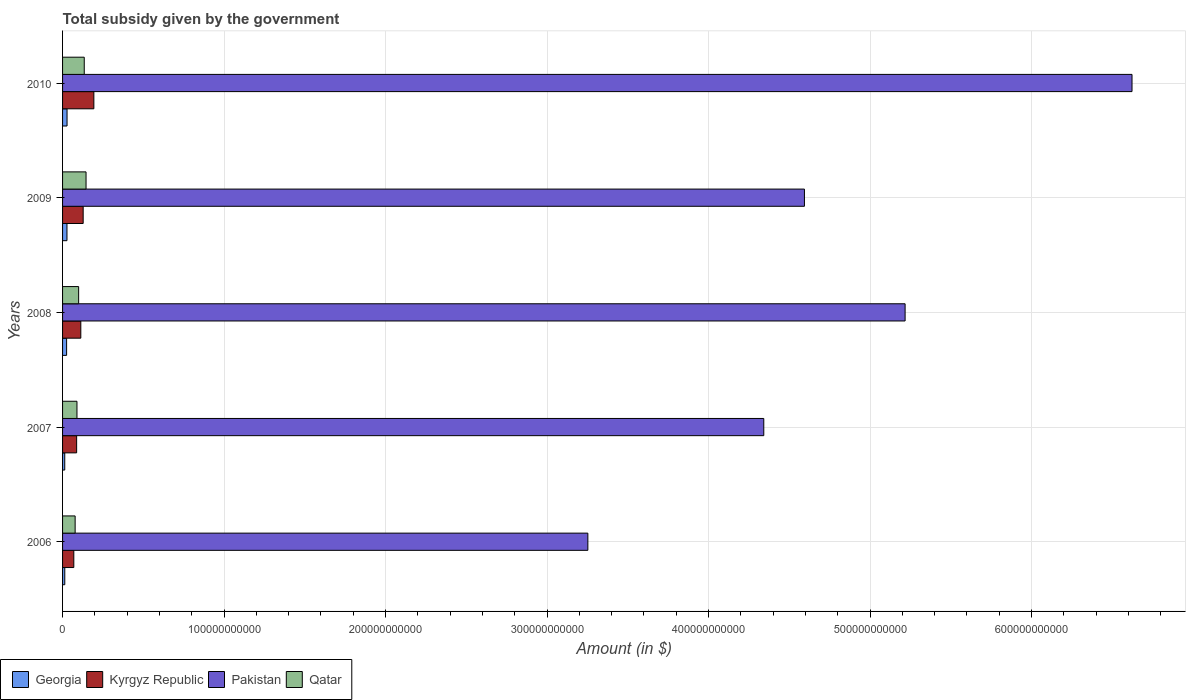Are the number of bars per tick equal to the number of legend labels?
Your answer should be very brief. Yes. What is the label of the 4th group of bars from the top?
Ensure brevity in your answer.  2007. In how many cases, is the number of bars for a given year not equal to the number of legend labels?
Provide a short and direct response. 0. What is the total revenue collected by the government in Qatar in 2008?
Your response must be concise. 9.95e+09. Across all years, what is the maximum total revenue collected by the government in Pakistan?
Provide a succinct answer. 6.62e+11. Across all years, what is the minimum total revenue collected by the government in Georgia?
Provide a short and direct response. 1.36e+09. In which year was the total revenue collected by the government in Kyrgyz Republic minimum?
Offer a very short reply. 2006. What is the total total revenue collected by the government in Georgia in the graph?
Offer a very short reply. 1.07e+1. What is the difference between the total revenue collected by the government in Kyrgyz Republic in 2006 and that in 2009?
Make the answer very short. -5.79e+09. What is the difference between the total revenue collected by the government in Kyrgyz Republic in 2009 and the total revenue collected by the government in Qatar in 2008?
Your answer should be very brief. 2.81e+09. What is the average total revenue collected by the government in Georgia per year?
Your response must be concise. 2.15e+09. In the year 2007, what is the difference between the total revenue collected by the government in Qatar and total revenue collected by the government in Kyrgyz Republic?
Offer a terse response. 2.00e+08. In how many years, is the total revenue collected by the government in Kyrgyz Republic greater than 600000000000 $?
Provide a succinct answer. 0. What is the ratio of the total revenue collected by the government in Kyrgyz Republic in 2006 to that in 2009?
Provide a short and direct response. 0.55. Is the total revenue collected by the government in Kyrgyz Republic in 2008 less than that in 2009?
Offer a very short reply. Yes. Is the difference between the total revenue collected by the government in Qatar in 2008 and 2009 greater than the difference between the total revenue collected by the government in Kyrgyz Republic in 2008 and 2009?
Provide a short and direct response. No. What is the difference between the highest and the second highest total revenue collected by the government in Georgia?
Keep it short and to the point. 4.86e+07. What is the difference between the highest and the lowest total revenue collected by the government in Pakistan?
Keep it short and to the point. 3.37e+11. Is the sum of the total revenue collected by the government in Pakistan in 2007 and 2008 greater than the maximum total revenue collected by the government in Qatar across all years?
Provide a succinct answer. Yes. What does the 2nd bar from the top in 2008 represents?
Keep it short and to the point. Pakistan. What does the 4th bar from the bottom in 2010 represents?
Make the answer very short. Qatar. Is it the case that in every year, the sum of the total revenue collected by the government in Pakistan and total revenue collected by the government in Kyrgyz Republic is greater than the total revenue collected by the government in Georgia?
Give a very brief answer. Yes. How many bars are there?
Give a very brief answer. 20. Are all the bars in the graph horizontal?
Give a very brief answer. Yes. What is the difference between two consecutive major ticks on the X-axis?
Give a very brief answer. 1.00e+11. Does the graph contain grids?
Provide a short and direct response. Yes. How are the legend labels stacked?
Your answer should be compact. Horizontal. What is the title of the graph?
Offer a terse response. Total subsidy given by the government. What is the label or title of the X-axis?
Offer a terse response. Amount (in $). What is the Amount (in $) of Georgia in 2006?
Offer a terse response. 1.37e+09. What is the Amount (in $) of Kyrgyz Republic in 2006?
Give a very brief answer. 6.97e+09. What is the Amount (in $) of Pakistan in 2006?
Your answer should be very brief. 3.25e+11. What is the Amount (in $) of Qatar in 2006?
Make the answer very short. 7.79e+09. What is the Amount (in $) in Georgia in 2007?
Give a very brief answer. 1.36e+09. What is the Amount (in $) of Kyrgyz Republic in 2007?
Offer a very short reply. 8.72e+09. What is the Amount (in $) in Pakistan in 2007?
Provide a short and direct response. 4.34e+11. What is the Amount (in $) of Qatar in 2007?
Ensure brevity in your answer.  8.92e+09. What is the Amount (in $) of Georgia in 2008?
Ensure brevity in your answer.  2.51e+09. What is the Amount (in $) of Kyrgyz Republic in 2008?
Your response must be concise. 1.13e+1. What is the Amount (in $) in Pakistan in 2008?
Your answer should be very brief. 5.22e+11. What is the Amount (in $) in Qatar in 2008?
Your answer should be compact. 9.95e+09. What is the Amount (in $) in Georgia in 2009?
Your answer should be very brief. 2.73e+09. What is the Amount (in $) of Kyrgyz Republic in 2009?
Provide a short and direct response. 1.28e+1. What is the Amount (in $) in Pakistan in 2009?
Your response must be concise. 4.59e+11. What is the Amount (in $) in Qatar in 2009?
Your answer should be compact. 1.45e+1. What is the Amount (in $) of Georgia in 2010?
Make the answer very short. 2.78e+09. What is the Amount (in $) in Kyrgyz Republic in 2010?
Give a very brief answer. 1.94e+1. What is the Amount (in $) of Pakistan in 2010?
Provide a succinct answer. 6.62e+11. What is the Amount (in $) in Qatar in 2010?
Your response must be concise. 1.34e+1. Across all years, what is the maximum Amount (in $) in Georgia?
Offer a terse response. 2.78e+09. Across all years, what is the maximum Amount (in $) of Kyrgyz Republic?
Your response must be concise. 1.94e+1. Across all years, what is the maximum Amount (in $) in Pakistan?
Provide a short and direct response. 6.62e+11. Across all years, what is the maximum Amount (in $) in Qatar?
Give a very brief answer. 1.45e+1. Across all years, what is the minimum Amount (in $) in Georgia?
Provide a short and direct response. 1.36e+09. Across all years, what is the minimum Amount (in $) of Kyrgyz Republic?
Provide a succinct answer. 6.97e+09. Across all years, what is the minimum Amount (in $) of Pakistan?
Make the answer very short. 3.25e+11. Across all years, what is the minimum Amount (in $) in Qatar?
Provide a short and direct response. 7.79e+09. What is the total Amount (in $) of Georgia in the graph?
Make the answer very short. 1.07e+1. What is the total Amount (in $) of Kyrgyz Republic in the graph?
Give a very brief answer. 5.91e+1. What is the total Amount (in $) in Pakistan in the graph?
Offer a very short reply. 2.40e+12. What is the total Amount (in $) of Qatar in the graph?
Provide a succinct answer. 5.46e+1. What is the difference between the Amount (in $) in Georgia in 2006 and that in 2007?
Your response must be concise. 1.25e+07. What is the difference between the Amount (in $) of Kyrgyz Republic in 2006 and that in 2007?
Provide a short and direct response. -1.75e+09. What is the difference between the Amount (in $) of Pakistan in 2006 and that in 2007?
Offer a very short reply. -1.09e+11. What is the difference between the Amount (in $) of Qatar in 2006 and that in 2007?
Make the answer very short. -1.13e+09. What is the difference between the Amount (in $) in Georgia in 2006 and that in 2008?
Your answer should be very brief. -1.14e+09. What is the difference between the Amount (in $) of Kyrgyz Republic in 2006 and that in 2008?
Make the answer very short. -4.34e+09. What is the difference between the Amount (in $) in Pakistan in 2006 and that in 2008?
Make the answer very short. -1.96e+11. What is the difference between the Amount (in $) in Qatar in 2006 and that in 2008?
Offer a terse response. -2.16e+09. What is the difference between the Amount (in $) in Georgia in 2006 and that in 2009?
Your response must be concise. -1.36e+09. What is the difference between the Amount (in $) of Kyrgyz Republic in 2006 and that in 2009?
Your response must be concise. -5.79e+09. What is the difference between the Amount (in $) in Pakistan in 2006 and that in 2009?
Offer a terse response. -1.34e+11. What is the difference between the Amount (in $) in Qatar in 2006 and that in 2009?
Give a very brief answer. -6.75e+09. What is the difference between the Amount (in $) in Georgia in 2006 and that in 2010?
Keep it short and to the point. -1.41e+09. What is the difference between the Amount (in $) of Kyrgyz Republic in 2006 and that in 2010?
Offer a terse response. -1.24e+1. What is the difference between the Amount (in $) in Pakistan in 2006 and that in 2010?
Your answer should be very brief. -3.37e+11. What is the difference between the Amount (in $) in Qatar in 2006 and that in 2010?
Keep it short and to the point. -5.64e+09. What is the difference between the Amount (in $) of Georgia in 2007 and that in 2008?
Offer a very short reply. -1.15e+09. What is the difference between the Amount (in $) in Kyrgyz Republic in 2007 and that in 2008?
Provide a succinct answer. -2.58e+09. What is the difference between the Amount (in $) of Pakistan in 2007 and that in 2008?
Make the answer very short. -8.75e+1. What is the difference between the Amount (in $) in Qatar in 2007 and that in 2008?
Offer a very short reply. -1.03e+09. What is the difference between the Amount (in $) in Georgia in 2007 and that in 2009?
Provide a succinct answer. -1.37e+09. What is the difference between the Amount (in $) in Kyrgyz Republic in 2007 and that in 2009?
Ensure brevity in your answer.  -4.04e+09. What is the difference between the Amount (in $) of Pakistan in 2007 and that in 2009?
Give a very brief answer. -2.52e+1. What is the difference between the Amount (in $) in Qatar in 2007 and that in 2009?
Ensure brevity in your answer.  -5.62e+09. What is the difference between the Amount (in $) of Georgia in 2007 and that in 2010?
Your answer should be very brief. -1.42e+09. What is the difference between the Amount (in $) in Kyrgyz Republic in 2007 and that in 2010?
Make the answer very short. -1.07e+1. What is the difference between the Amount (in $) in Pakistan in 2007 and that in 2010?
Your answer should be compact. -2.28e+11. What is the difference between the Amount (in $) in Qatar in 2007 and that in 2010?
Provide a succinct answer. -4.51e+09. What is the difference between the Amount (in $) in Georgia in 2008 and that in 2009?
Offer a terse response. -2.21e+08. What is the difference between the Amount (in $) in Kyrgyz Republic in 2008 and that in 2009?
Offer a terse response. -1.46e+09. What is the difference between the Amount (in $) of Pakistan in 2008 and that in 2009?
Ensure brevity in your answer.  6.23e+1. What is the difference between the Amount (in $) of Qatar in 2008 and that in 2009?
Your answer should be compact. -4.59e+09. What is the difference between the Amount (in $) of Georgia in 2008 and that in 2010?
Provide a succinct answer. -2.70e+08. What is the difference between the Amount (in $) of Kyrgyz Republic in 2008 and that in 2010?
Your answer should be very brief. -8.08e+09. What is the difference between the Amount (in $) of Pakistan in 2008 and that in 2010?
Give a very brief answer. -1.41e+11. What is the difference between the Amount (in $) of Qatar in 2008 and that in 2010?
Your response must be concise. -3.48e+09. What is the difference between the Amount (in $) of Georgia in 2009 and that in 2010?
Offer a very short reply. -4.86e+07. What is the difference between the Amount (in $) in Kyrgyz Republic in 2009 and that in 2010?
Your answer should be compact. -6.62e+09. What is the difference between the Amount (in $) in Pakistan in 2009 and that in 2010?
Your response must be concise. -2.03e+11. What is the difference between the Amount (in $) of Qatar in 2009 and that in 2010?
Provide a short and direct response. 1.11e+09. What is the difference between the Amount (in $) in Georgia in 2006 and the Amount (in $) in Kyrgyz Republic in 2007?
Provide a short and direct response. -7.35e+09. What is the difference between the Amount (in $) of Georgia in 2006 and the Amount (in $) of Pakistan in 2007?
Your answer should be very brief. -4.33e+11. What is the difference between the Amount (in $) in Georgia in 2006 and the Amount (in $) in Qatar in 2007?
Your answer should be compact. -7.55e+09. What is the difference between the Amount (in $) of Kyrgyz Republic in 2006 and the Amount (in $) of Pakistan in 2007?
Ensure brevity in your answer.  -4.27e+11. What is the difference between the Amount (in $) in Kyrgyz Republic in 2006 and the Amount (in $) in Qatar in 2007?
Provide a succinct answer. -1.95e+09. What is the difference between the Amount (in $) of Pakistan in 2006 and the Amount (in $) of Qatar in 2007?
Give a very brief answer. 3.16e+11. What is the difference between the Amount (in $) of Georgia in 2006 and the Amount (in $) of Kyrgyz Republic in 2008?
Provide a succinct answer. -9.93e+09. What is the difference between the Amount (in $) of Georgia in 2006 and the Amount (in $) of Pakistan in 2008?
Offer a terse response. -5.20e+11. What is the difference between the Amount (in $) in Georgia in 2006 and the Amount (in $) in Qatar in 2008?
Ensure brevity in your answer.  -8.58e+09. What is the difference between the Amount (in $) in Kyrgyz Republic in 2006 and the Amount (in $) in Pakistan in 2008?
Make the answer very short. -5.15e+11. What is the difference between the Amount (in $) in Kyrgyz Republic in 2006 and the Amount (in $) in Qatar in 2008?
Provide a short and direct response. -2.99e+09. What is the difference between the Amount (in $) in Pakistan in 2006 and the Amount (in $) in Qatar in 2008?
Keep it short and to the point. 3.15e+11. What is the difference between the Amount (in $) of Georgia in 2006 and the Amount (in $) of Kyrgyz Republic in 2009?
Provide a short and direct response. -1.14e+1. What is the difference between the Amount (in $) of Georgia in 2006 and the Amount (in $) of Pakistan in 2009?
Provide a short and direct response. -4.58e+11. What is the difference between the Amount (in $) in Georgia in 2006 and the Amount (in $) in Qatar in 2009?
Provide a short and direct response. -1.32e+1. What is the difference between the Amount (in $) of Kyrgyz Republic in 2006 and the Amount (in $) of Pakistan in 2009?
Offer a very short reply. -4.52e+11. What is the difference between the Amount (in $) in Kyrgyz Republic in 2006 and the Amount (in $) in Qatar in 2009?
Ensure brevity in your answer.  -7.57e+09. What is the difference between the Amount (in $) in Pakistan in 2006 and the Amount (in $) in Qatar in 2009?
Provide a short and direct response. 3.11e+11. What is the difference between the Amount (in $) in Georgia in 2006 and the Amount (in $) in Kyrgyz Republic in 2010?
Provide a short and direct response. -1.80e+1. What is the difference between the Amount (in $) in Georgia in 2006 and the Amount (in $) in Pakistan in 2010?
Offer a very short reply. -6.61e+11. What is the difference between the Amount (in $) of Georgia in 2006 and the Amount (in $) of Qatar in 2010?
Provide a short and direct response. -1.21e+1. What is the difference between the Amount (in $) in Kyrgyz Republic in 2006 and the Amount (in $) in Pakistan in 2010?
Give a very brief answer. -6.55e+11. What is the difference between the Amount (in $) in Kyrgyz Republic in 2006 and the Amount (in $) in Qatar in 2010?
Provide a short and direct response. -6.47e+09. What is the difference between the Amount (in $) of Pakistan in 2006 and the Amount (in $) of Qatar in 2010?
Give a very brief answer. 3.12e+11. What is the difference between the Amount (in $) of Georgia in 2007 and the Amount (in $) of Kyrgyz Republic in 2008?
Offer a very short reply. -9.95e+09. What is the difference between the Amount (in $) of Georgia in 2007 and the Amount (in $) of Pakistan in 2008?
Your response must be concise. -5.20e+11. What is the difference between the Amount (in $) of Georgia in 2007 and the Amount (in $) of Qatar in 2008?
Provide a succinct answer. -8.60e+09. What is the difference between the Amount (in $) in Kyrgyz Republic in 2007 and the Amount (in $) in Pakistan in 2008?
Your answer should be compact. -5.13e+11. What is the difference between the Amount (in $) in Kyrgyz Republic in 2007 and the Amount (in $) in Qatar in 2008?
Give a very brief answer. -1.23e+09. What is the difference between the Amount (in $) of Pakistan in 2007 and the Amount (in $) of Qatar in 2008?
Your answer should be compact. 4.24e+11. What is the difference between the Amount (in $) of Georgia in 2007 and the Amount (in $) of Kyrgyz Republic in 2009?
Make the answer very short. -1.14e+1. What is the difference between the Amount (in $) of Georgia in 2007 and the Amount (in $) of Pakistan in 2009?
Keep it short and to the point. -4.58e+11. What is the difference between the Amount (in $) in Georgia in 2007 and the Amount (in $) in Qatar in 2009?
Your answer should be very brief. -1.32e+1. What is the difference between the Amount (in $) in Kyrgyz Republic in 2007 and the Amount (in $) in Pakistan in 2009?
Make the answer very short. -4.51e+11. What is the difference between the Amount (in $) of Kyrgyz Republic in 2007 and the Amount (in $) of Qatar in 2009?
Your response must be concise. -5.82e+09. What is the difference between the Amount (in $) of Pakistan in 2007 and the Amount (in $) of Qatar in 2009?
Ensure brevity in your answer.  4.20e+11. What is the difference between the Amount (in $) of Georgia in 2007 and the Amount (in $) of Kyrgyz Republic in 2010?
Your response must be concise. -1.80e+1. What is the difference between the Amount (in $) of Georgia in 2007 and the Amount (in $) of Pakistan in 2010?
Offer a terse response. -6.61e+11. What is the difference between the Amount (in $) in Georgia in 2007 and the Amount (in $) in Qatar in 2010?
Your response must be concise. -1.21e+1. What is the difference between the Amount (in $) in Kyrgyz Republic in 2007 and the Amount (in $) in Pakistan in 2010?
Your response must be concise. -6.54e+11. What is the difference between the Amount (in $) in Kyrgyz Republic in 2007 and the Amount (in $) in Qatar in 2010?
Your answer should be very brief. -4.71e+09. What is the difference between the Amount (in $) of Pakistan in 2007 and the Amount (in $) of Qatar in 2010?
Offer a terse response. 4.21e+11. What is the difference between the Amount (in $) in Georgia in 2008 and the Amount (in $) in Kyrgyz Republic in 2009?
Provide a short and direct response. -1.03e+1. What is the difference between the Amount (in $) in Georgia in 2008 and the Amount (in $) in Pakistan in 2009?
Offer a very short reply. -4.57e+11. What is the difference between the Amount (in $) of Georgia in 2008 and the Amount (in $) of Qatar in 2009?
Your answer should be very brief. -1.20e+1. What is the difference between the Amount (in $) of Kyrgyz Republic in 2008 and the Amount (in $) of Pakistan in 2009?
Make the answer very short. -4.48e+11. What is the difference between the Amount (in $) of Kyrgyz Republic in 2008 and the Amount (in $) of Qatar in 2009?
Make the answer very short. -3.24e+09. What is the difference between the Amount (in $) of Pakistan in 2008 and the Amount (in $) of Qatar in 2009?
Ensure brevity in your answer.  5.07e+11. What is the difference between the Amount (in $) in Georgia in 2008 and the Amount (in $) in Kyrgyz Republic in 2010?
Provide a short and direct response. -1.69e+1. What is the difference between the Amount (in $) of Georgia in 2008 and the Amount (in $) of Pakistan in 2010?
Provide a succinct answer. -6.60e+11. What is the difference between the Amount (in $) in Georgia in 2008 and the Amount (in $) in Qatar in 2010?
Ensure brevity in your answer.  -1.09e+1. What is the difference between the Amount (in $) in Kyrgyz Republic in 2008 and the Amount (in $) in Pakistan in 2010?
Provide a short and direct response. -6.51e+11. What is the difference between the Amount (in $) in Kyrgyz Republic in 2008 and the Amount (in $) in Qatar in 2010?
Offer a terse response. -2.13e+09. What is the difference between the Amount (in $) in Pakistan in 2008 and the Amount (in $) in Qatar in 2010?
Your answer should be very brief. 5.08e+11. What is the difference between the Amount (in $) of Georgia in 2009 and the Amount (in $) of Kyrgyz Republic in 2010?
Make the answer very short. -1.67e+1. What is the difference between the Amount (in $) in Georgia in 2009 and the Amount (in $) in Pakistan in 2010?
Your response must be concise. -6.60e+11. What is the difference between the Amount (in $) in Georgia in 2009 and the Amount (in $) in Qatar in 2010?
Provide a succinct answer. -1.07e+1. What is the difference between the Amount (in $) in Kyrgyz Republic in 2009 and the Amount (in $) in Pakistan in 2010?
Ensure brevity in your answer.  -6.49e+11. What is the difference between the Amount (in $) in Kyrgyz Republic in 2009 and the Amount (in $) in Qatar in 2010?
Give a very brief answer. -6.71e+08. What is the difference between the Amount (in $) of Pakistan in 2009 and the Amount (in $) of Qatar in 2010?
Your answer should be compact. 4.46e+11. What is the average Amount (in $) of Georgia per year?
Make the answer very short. 2.15e+09. What is the average Amount (in $) of Kyrgyz Republic per year?
Ensure brevity in your answer.  1.18e+1. What is the average Amount (in $) of Pakistan per year?
Make the answer very short. 4.81e+11. What is the average Amount (in $) of Qatar per year?
Your response must be concise. 1.09e+1. In the year 2006, what is the difference between the Amount (in $) of Georgia and Amount (in $) of Kyrgyz Republic?
Offer a very short reply. -5.60e+09. In the year 2006, what is the difference between the Amount (in $) in Georgia and Amount (in $) in Pakistan?
Give a very brief answer. -3.24e+11. In the year 2006, what is the difference between the Amount (in $) in Georgia and Amount (in $) in Qatar?
Provide a short and direct response. -6.42e+09. In the year 2006, what is the difference between the Amount (in $) in Kyrgyz Republic and Amount (in $) in Pakistan?
Make the answer very short. -3.18e+11. In the year 2006, what is the difference between the Amount (in $) of Kyrgyz Republic and Amount (in $) of Qatar?
Keep it short and to the point. -8.22e+08. In the year 2006, what is the difference between the Amount (in $) of Pakistan and Amount (in $) of Qatar?
Keep it short and to the point. 3.17e+11. In the year 2007, what is the difference between the Amount (in $) of Georgia and Amount (in $) of Kyrgyz Republic?
Offer a very short reply. -7.36e+09. In the year 2007, what is the difference between the Amount (in $) in Georgia and Amount (in $) in Pakistan?
Keep it short and to the point. -4.33e+11. In the year 2007, what is the difference between the Amount (in $) in Georgia and Amount (in $) in Qatar?
Ensure brevity in your answer.  -7.56e+09. In the year 2007, what is the difference between the Amount (in $) of Kyrgyz Republic and Amount (in $) of Pakistan?
Provide a short and direct response. -4.26e+11. In the year 2007, what is the difference between the Amount (in $) in Kyrgyz Republic and Amount (in $) in Qatar?
Offer a terse response. -2.00e+08. In the year 2007, what is the difference between the Amount (in $) in Pakistan and Amount (in $) in Qatar?
Offer a very short reply. 4.25e+11. In the year 2008, what is the difference between the Amount (in $) in Georgia and Amount (in $) in Kyrgyz Republic?
Offer a very short reply. -8.80e+09. In the year 2008, what is the difference between the Amount (in $) in Georgia and Amount (in $) in Pakistan?
Give a very brief answer. -5.19e+11. In the year 2008, what is the difference between the Amount (in $) of Georgia and Amount (in $) of Qatar?
Your response must be concise. -7.45e+09. In the year 2008, what is the difference between the Amount (in $) in Kyrgyz Republic and Amount (in $) in Pakistan?
Offer a very short reply. -5.10e+11. In the year 2008, what is the difference between the Amount (in $) in Kyrgyz Republic and Amount (in $) in Qatar?
Give a very brief answer. 1.35e+09. In the year 2008, what is the difference between the Amount (in $) in Pakistan and Amount (in $) in Qatar?
Your answer should be very brief. 5.12e+11. In the year 2009, what is the difference between the Amount (in $) of Georgia and Amount (in $) of Kyrgyz Republic?
Your response must be concise. -1.00e+1. In the year 2009, what is the difference between the Amount (in $) of Georgia and Amount (in $) of Pakistan?
Offer a very short reply. -4.57e+11. In the year 2009, what is the difference between the Amount (in $) in Georgia and Amount (in $) in Qatar?
Provide a succinct answer. -1.18e+1. In the year 2009, what is the difference between the Amount (in $) in Kyrgyz Republic and Amount (in $) in Pakistan?
Your answer should be compact. -4.47e+11. In the year 2009, what is the difference between the Amount (in $) of Kyrgyz Republic and Amount (in $) of Qatar?
Your answer should be compact. -1.78e+09. In the year 2009, what is the difference between the Amount (in $) of Pakistan and Amount (in $) of Qatar?
Your answer should be very brief. 4.45e+11. In the year 2010, what is the difference between the Amount (in $) of Georgia and Amount (in $) of Kyrgyz Republic?
Provide a succinct answer. -1.66e+1. In the year 2010, what is the difference between the Amount (in $) in Georgia and Amount (in $) in Pakistan?
Make the answer very short. -6.59e+11. In the year 2010, what is the difference between the Amount (in $) of Georgia and Amount (in $) of Qatar?
Offer a very short reply. -1.07e+1. In the year 2010, what is the difference between the Amount (in $) in Kyrgyz Republic and Amount (in $) in Pakistan?
Provide a succinct answer. -6.43e+11. In the year 2010, what is the difference between the Amount (in $) of Kyrgyz Republic and Amount (in $) of Qatar?
Make the answer very short. 5.95e+09. In the year 2010, what is the difference between the Amount (in $) of Pakistan and Amount (in $) of Qatar?
Give a very brief answer. 6.49e+11. What is the ratio of the Amount (in $) of Georgia in 2006 to that in 2007?
Your answer should be compact. 1.01. What is the ratio of the Amount (in $) of Kyrgyz Republic in 2006 to that in 2007?
Your response must be concise. 0.8. What is the ratio of the Amount (in $) in Pakistan in 2006 to that in 2007?
Make the answer very short. 0.75. What is the ratio of the Amount (in $) in Qatar in 2006 to that in 2007?
Offer a terse response. 0.87. What is the ratio of the Amount (in $) of Georgia in 2006 to that in 2008?
Your answer should be compact. 0.55. What is the ratio of the Amount (in $) of Kyrgyz Republic in 2006 to that in 2008?
Your answer should be very brief. 0.62. What is the ratio of the Amount (in $) in Pakistan in 2006 to that in 2008?
Offer a terse response. 0.62. What is the ratio of the Amount (in $) in Qatar in 2006 to that in 2008?
Make the answer very short. 0.78. What is the ratio of the Amount (in $) in Georgia in 2006 to that in 2009?
Make the answer very short. 0.5. What is the ratio of the Amount (in $) of Kyrgyz Republic in 2006 to that in 2009?
Ensure brevity in your answer.  0.55. What is the ratio of the Amount (in $) in Pakistan in 2006 to that in 2009?
Offer a terse response. 0.71. What is the ratio of the Amount (in $) of Qatar in 2006 to that in 2009?
Offer a terse response. 0.54. What is the ratio of the Amount (in $) in Georgia in 2006 to that in 2010?
Provide a short and direct response. 0.49. What is the ratio of the Amount (in $) of Kyrgyz Republic in 2006 to that in 2010?
Keep it short and to the point. 0.36. What is the ratio of the Amount (in $) of Pakistan in 2006 to that in 2010?
Make the answer very short. 0.49. What is the ratio of the Amount (in $) of Qatar in 2006 to that in 2010?
Your answer should be compact. 0.58. What is the ratio of the Amount (in $) in Georgia in 2007 to that in 2008?
Ensure brevity in your answer.  0.54. What is the ratio of the Amount (in $) in Kyrgyz Republic in 2007 to that in 2008?
Provide a succinct answer. 0.77. What is the ratio of the Amount (in $) in Pakistan in 2007 to that in 2008?
Offer a very short reply. 0.83. What is the ratio of the Amount (in $) in Qatar in 2007 to that in 2008?
Offer a very short reply. 0.9. What is the ratio of the Amount (in $) of Georgia in 2007 to that in 2009?
Offer a terse response. 0.5. What is the ratio of the Amount (in $) in Kyrgyz Republic in 2007 to that in 2009?
Ensure brevity in your answer.  0.68. What is the ratio of the Amount (in $) in Pakistan in 2007 to that in 2009?
Make the answer very short. 0.95. What is the ratio of the Amount (in $) in Qatar in 2007 to that in 2009?
Ensure brevity in your answer.  0.61. What is the ratio of the Amount (in $) in Georgia in 2007 to that in 2010?
Keep it short and to the point. 0.49. What is the ratio of the Amount (in $) in Kyrgyz Republic in 2007 to that in 2010?
Your answer should be compact. 0.45. What is the ratio of the Amount (in $) in Pakistan in 2007 to that in 2010?
Your answer should be compact. 0.66. What is the ratio of the Amount (in $) of Qatar in 2007 to that in 2010?
Provide a short and direct response. 0.66. What is the ratio of the Amount (in $) of Georgia in 2008 to that in 2009?
Keep it short and to the point. 0.92. What is the ratio of the Amount (in $) in Kyrgyz Republic in 2008 to that in 2009?
Make the answer very short. 0.89. What is the ratio of the Amount (in $) in Pakistan in 2008 to that in 2009?
Offer a terse response. 1.14. What is the ratio of the Amount (in $) of Qatar in 2008 to that in 2009?
Give a very brief answer. 0.68. What is the ratio of the Amount (in $) of Georgia in 2008 to that in 2010?
Ensure brevity in your answer.  0.9. What is the ratio of the Amount (in $) in Kyrgyz Republic in 2008 to that in 2010?
Ensure brevity in your answer.  0.58. What is the ratio of the Amount (in $) of Pakistan in 2008 to that in 2010?
Provide a short and direct response. 0.79. What is the ratio of the Amount (in $) of Qatar in 2008 to that in 2010?
Give a very brief answer. 0.74. What is the ratio of the Amount (in $) in Georgia in 2009 to that in 2010?
Offer a very short reply. 0.98. What is the ratio of the Amount (in $) in Kyrgyz Republic in 2009 to that in 2010?
Your answer should be very brief. 0.66. What is the ratio of the Amount (in $) of Pakistan in 2009 to that in 2010?
Your answer should be very brief. 0.69. What is the ratio of the Amount (in $) of Qatar in 2009 to that in 2010?
Provide a succinct answer. 1.08. What is the difference between the highest and the second highest Amount (in $) of Georgia?
Offer a terse response. 4.86e+07. What is the difference between the highest and the second highest Amount (in $) in Kyrgyz Republic?
Give a very brief answer. 6.62e+09. What is the difference between the highest and the second highest Amount (in $) in Pakistan?
Keep it short and to the point. 1.41e+11. What is the difference between the highest and the second highest Amount (in $) in Qatar?
Offer a terse response. 1.11e+09. What is the difference between the highest and the lowest Amount (in $) of Georgia?
Your answer should be compact. 1.42e+09. What is the difference between the highest and the lowest Amount (in $) of Kyrgyz Republic?
Provide a succinct answer. 1.24e+1. What is the difference between the highest and the lowest Amount (in $) of Pakistan?
Keep it short and to the point. 3.37e+11. What is the difference between the highest and the lowest Amount (in $) of Qatar?
Give a very brief answer. 6.75e+09. 